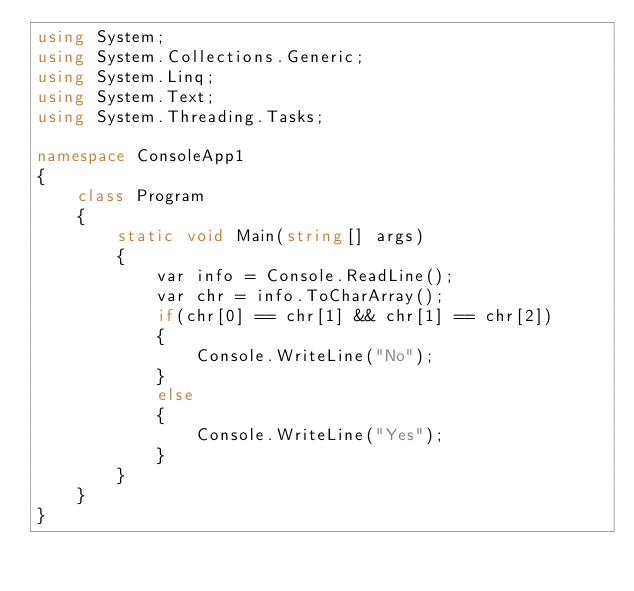<code> <loc_0><loc_0><loc_500><loc_500><_C#_>using System;
using System.Collections.Generic;
using System.Linq;
using System.Text;
using System.Threading.Tasks;

namespace ConsoleApp1
{
    class Program
    {
        static void Main(string[] args)
        {
            var info = Console.ReadLine();
            var chr = info.ToCharArray();
            if(chr[0] == chr[1] && chr[1] == chr[2])
            {
                Console.WriteLine("No");
            }
            else
            {
                Console.WriteLine("Yes");
            }
        }
    }
}</code> 